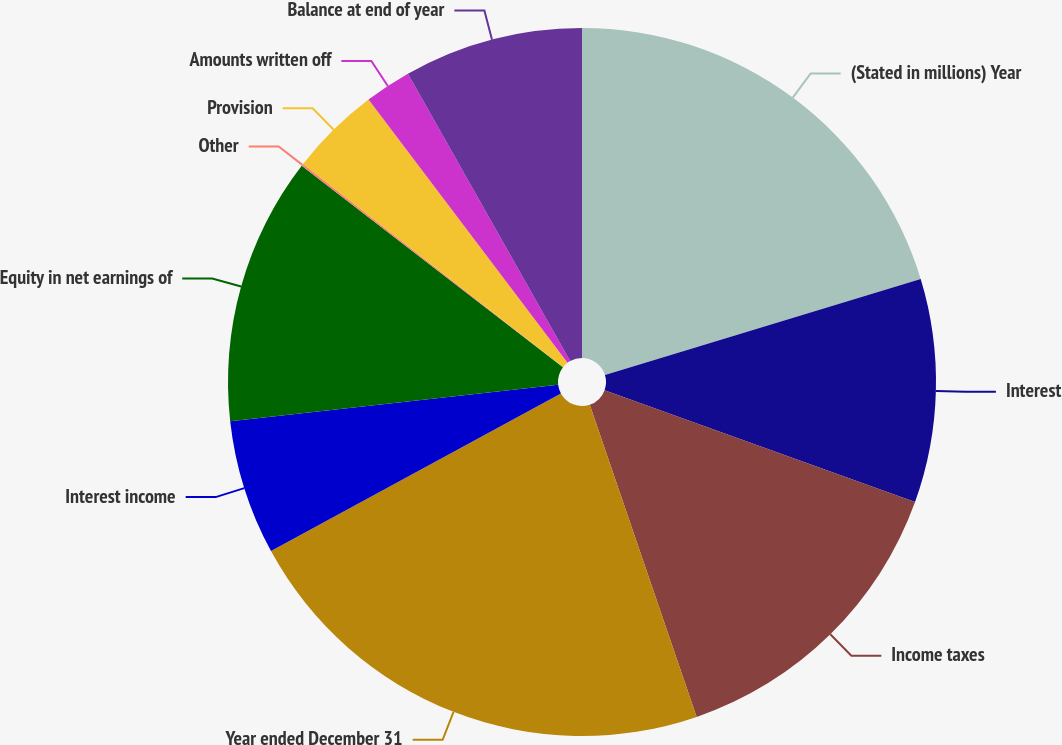Convert chart. <chart><loc_0><loc_0><loc_500><loc_500><pie_chart><fcel>(Stated in millions) Year<fcel>Interest<fcel>Income taxes<fcel>Year ended December 31<fcel>Interest income<fcel>Equity in net earnings of<fcel>Other<fcel>Provision<fcel>Amounts written off<fcel>Balance at end of year<nl><fcel>20.3%<fcel>10.2%<fcel>14.24%<fcel>22.32%<fcel>6.16%<fcel>12.22%<fcel>0.1%<fcel>4.14%<fcel>2.12%<fcel>8.18%<nl></chart> 